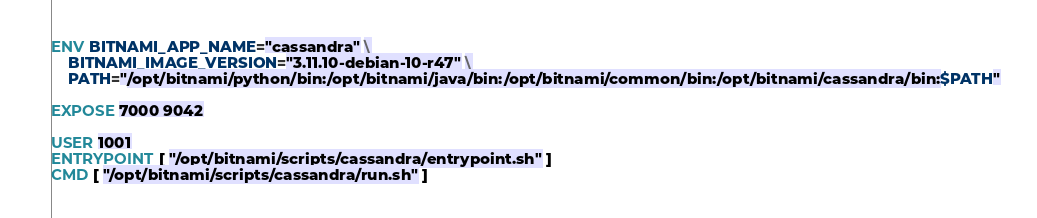Convert code to text. <code><loc_0><loc_0><loc_500><loc_500><_Dockerfile_>ENV BITNAMI_APP_NAME="cassandra" \
    BITNAMI_IMAGE_VERSION="3.11.10-debian-10-r47" \
    PATH="/opt/bitnami/python/bin:/opt/bitnami/java/bin:/opt/bitnami/common/bin:/opt/bitnami/cassandra/bin:$PATH"

EXPOSE 7000 9042

USER 1001
ENTRYPOINT [ "/opt/bitnami/scripts/cassandra/entrypoint.sh" ]
CMD [ "/opt/bitnami/scripts/cassandra/run.sh" ]
</code> 